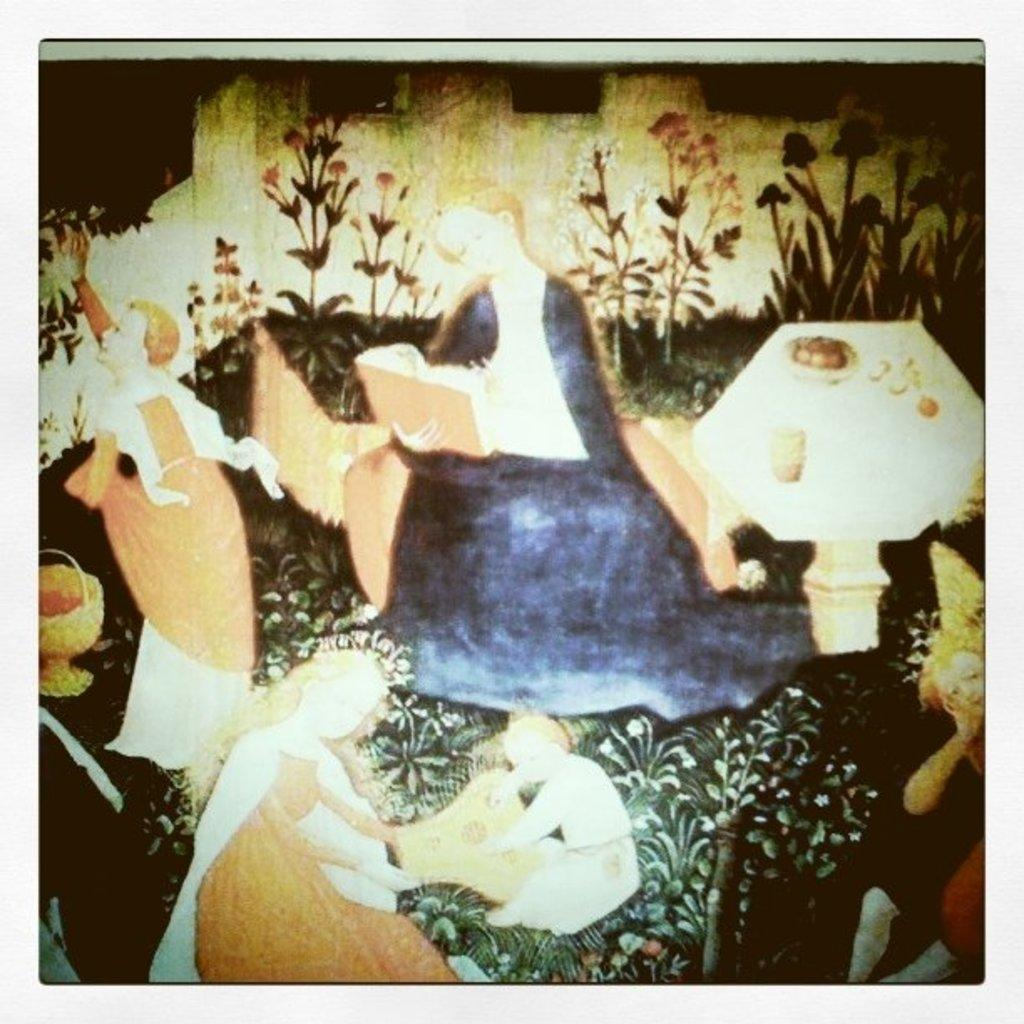What types of subjects are depicted in the painting? The painting contains people and plants. Are there any furniture items in the painting? Yes, there is a table and a sofa in the painting. What is the lady holding in the painting? The lady is holding a book in the painting. What is the lady doing with the book? The lady is reading something in the painting. What type of list can be seen hanging on the wall in the painting? There is no list visible in the painting; it only shows a lady holding a book and reading. 